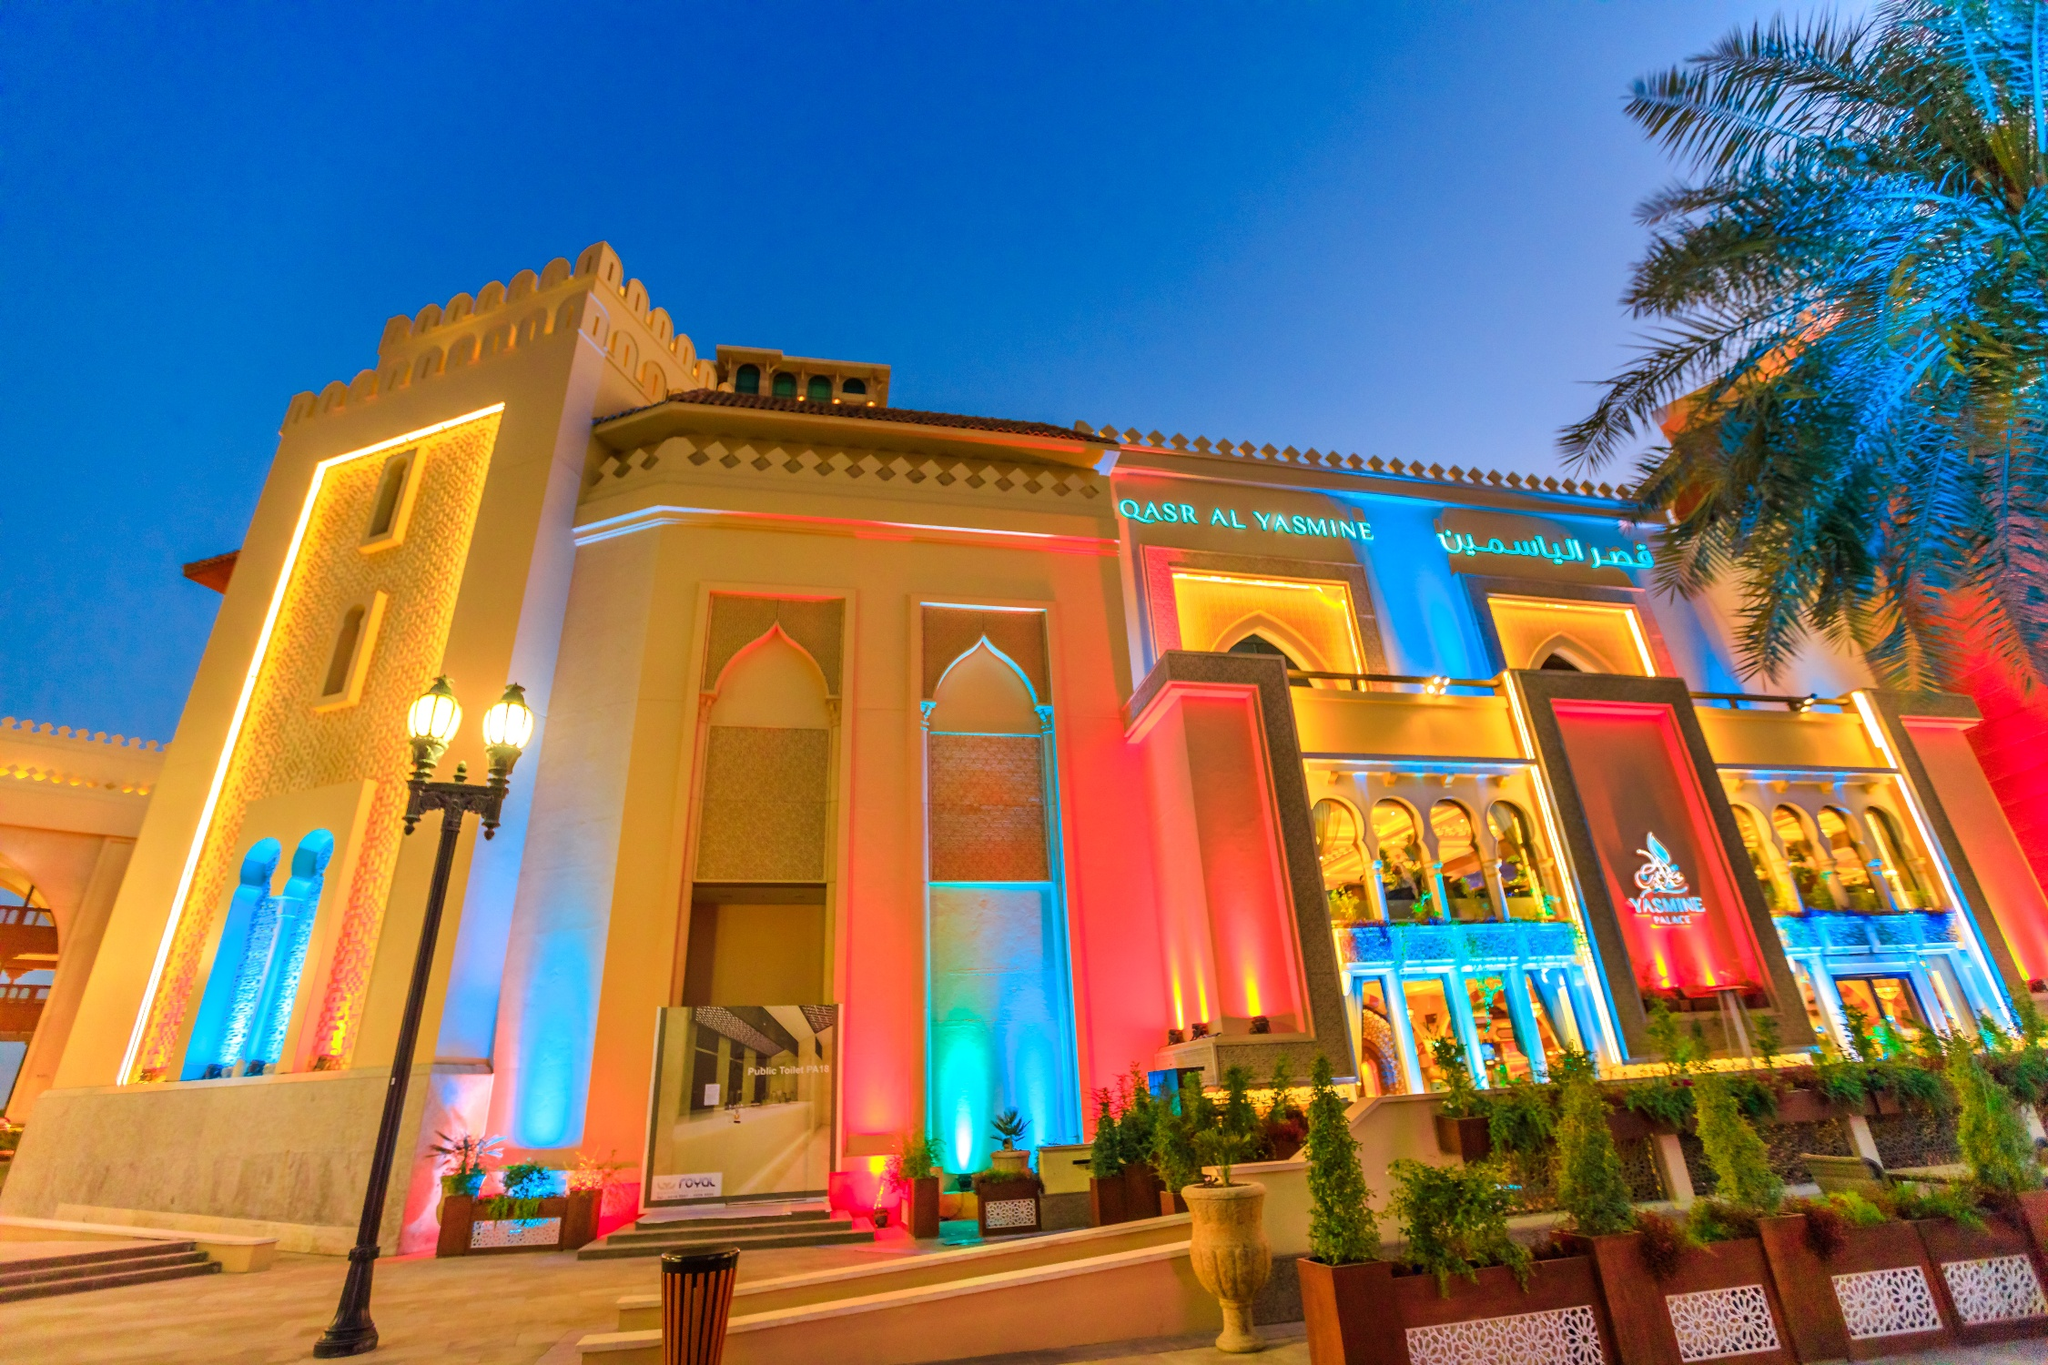Analyze the image in a comprehensive and detailed manner.
 The image captures the grandeur of Qasr Al Watan, a palace located in Abu Dhabi, United Arab Emirates. The palace, a stunning example of traditional Arabic architectural style, is bathed in a spectrum of vibrant lights that bring its white and gold accents to life. The perspective of the photo, taken from a low angle, enhances the majesty of the palace, making it appear as if it's reaching for the deep blue sky above. In the foreground, palm trees lit with blue and red lights add to the festive atmosphere, their fronds swaying gently against the backdrop of the illuminated palace. The image is a beautiful representation of the fusion of tradition and modernity that characterizes the United Arab Emirates. 